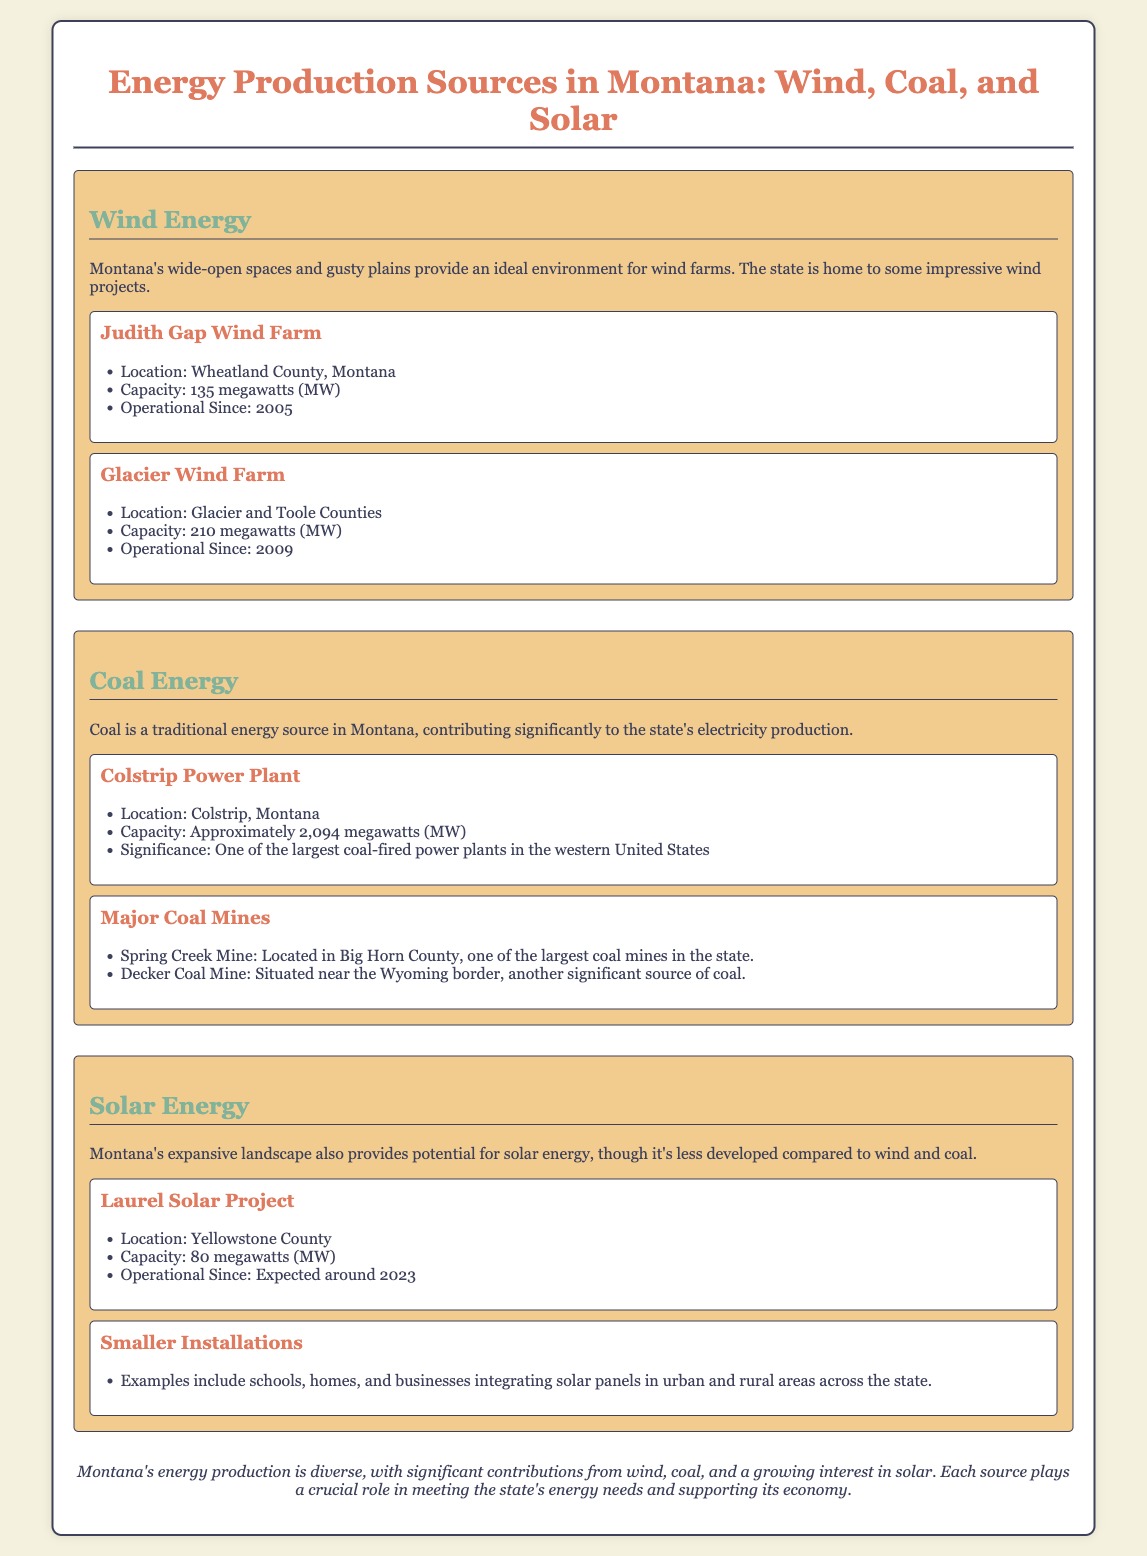what is the capacity of Judith Gap Wind Farm? The document states that the Judith Gap Wind Farm has a capacity of 135 megawatts (MW).
Answer: 135 megawatts (MW) where is the Colstrip Power Plant located? The document specifies that the Colstrip Power Plant is located in Colstrip, Montana.
Answer: Colstrip, Montana what year did the Glacier Wind Farm become operational? According to the document, the Glacier Wind Farm has been operational since 2009.
Answer: 2009 what is the total capacity of coal energy mentioned for the Colstrip Power Plant? The document notes that the capacity for the Colstrip Power Plant is approximately 2,094 megawatts (MW).
Answer: approximately 2,094 megawatts (MW) which energy source has the least development mentioned in the document? The document indicates that solar energy is less developed compared to wind and coal.
Answer: solar energy how many megawatts is the Laurel Solar Project expected to have? The document states that the Laurel Solar Project has a capacity of 80 megawatts (MW).
Answer: 80 megawatts (MW) what is a significant coal mine mentioned in the document? The document mentions that the Spring Creek Mine is one of the largest coal mines in the state.
Answer: Spring Creek Mine what is a key feature of Montana's energy production? The document concludes that Montana's energy production is diverse with significant contributions from multiple sources.
Answer: diverse 